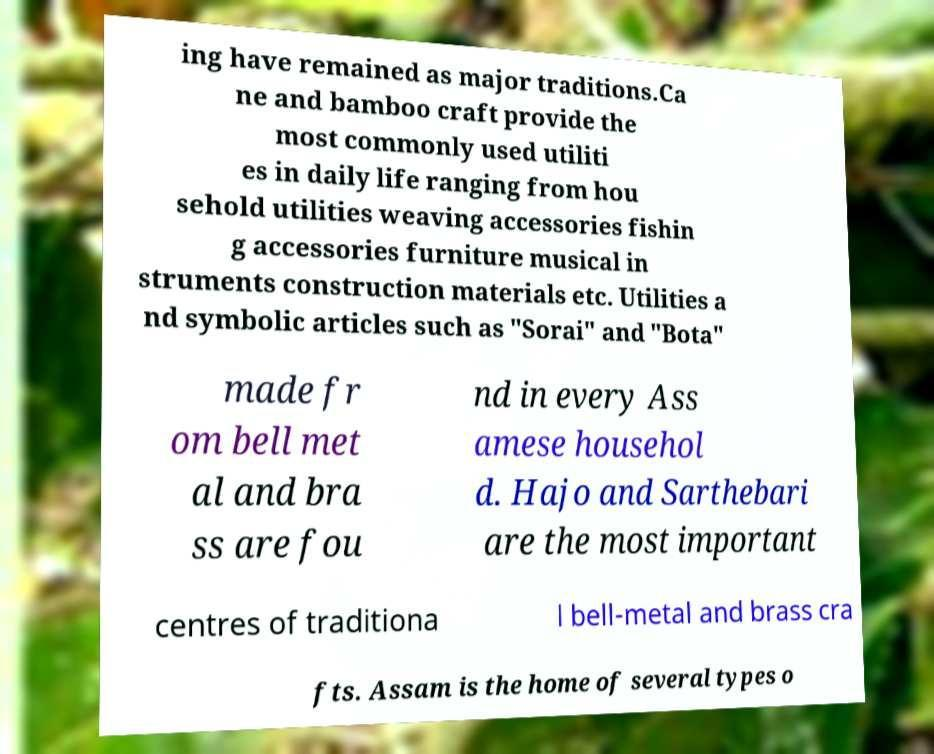Could you assist in decoding the text presented in this image and type it out clearly? ing have remained as major traditions.Ca ne and bamboo craft provide the most commonly used utiliti es in daily life ranging from hou sehold utilities weaving accessories fishin g accessories furniture musical in struments construction materials etc. Utilities a nd symbolic articles such as "Sorai" and "Bota" made fr om bell met al and bra ss are fou nd in every Ass amese househol d. Hajo and Sarthebari are the most important centres of traditiona l bell-metal and brass cra fts. Assam is the home of several types o 